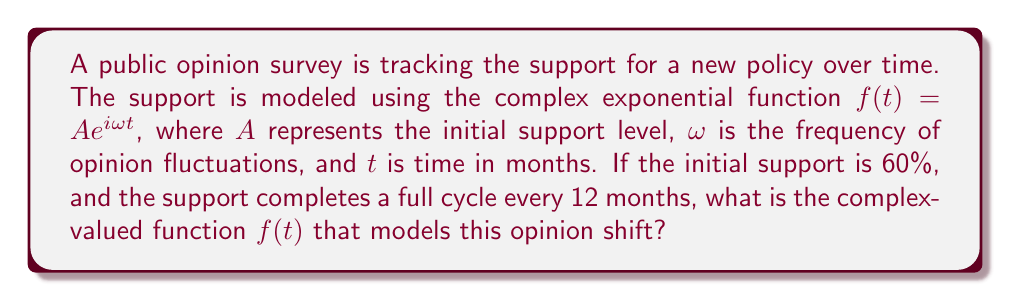Provide a solution to this math problem. To solve this problem, we need to determine the values of $A$ and $\omega$ in the given complex exponential function $f(t) = Ae^{i\omega t}$.

1. Initial support level (A):
   The initial support is given as 60%, which in decimal form is 0.60.
   Therefore, $A = 0.60$

2. Frequency of opinion fluctuations (ω):
   We know that the support completes a full cycle every 12 months.
   In complex analysis, a full cycle corresponds to $2\pi$ radians.
   So, we can set up the equation:
   $\omega \cdot 12 = 2\pi$
   Solving for $\omega$:
   $\omega = \frac{2\pi}{12} = \frac{\pi}{6}$

Now that we have both $A$ and $\omega$, we can substitute these values into the original function:

$f(t) = 0.60 \cdot e^{i\frac{\pi}{6}t}$

This complex-valued function models the opinion shift over time, where $t$ is measured in months.
Answer: $f(t) = 0.60 \cdot e^{i\frac{\pi}{6}t}$ 